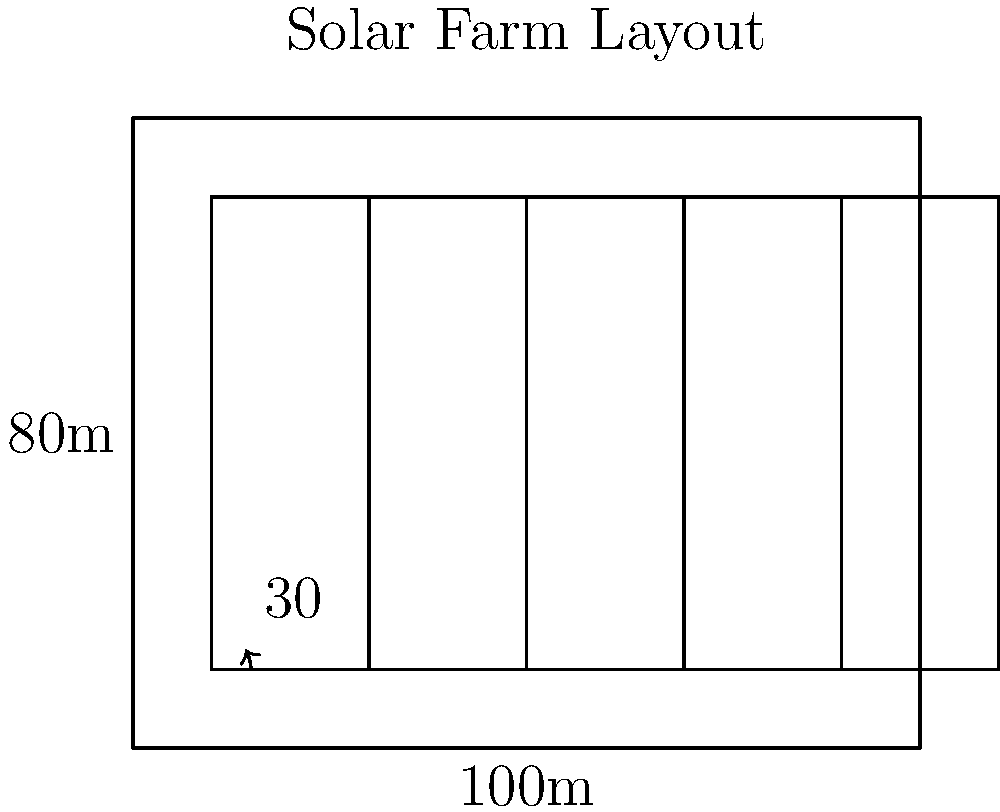A rectangular plot of land measuring 100m by 80m is available for a solar farm. Solar panels are to be arranged in rows, with each panel tilted at a 30° angle from the horizontal. To minimize shading, the distance between rows should be 2.5 times the vertical height of a tilted panel. If each panel is 20m wide and 60m long when laid flat, what is the maximum number of complete rows of panels that can be installed in this plot? To solve this problem, we need to follow these steps:

1) First, calculate the vertical height of a tilted panel:
   $h = 60m \cdot \sin(30°) = 60m \cdot 0.5 = 30m$

2) Calculate the required distance between rows:
   $d = 2.5 \cdot h = 2.5 \cdot 30m = 75m$

3) The total space needed for one row (including the gap):
   $\text{Total space} = 75m + 60m \cdot \cos(30°) = 75m + 60m \cdot 0.866 = 127m$

4) The available space is 80m (the width of the plot). To find the number of rows, divide the available space by the total space needed per row:
   $\text{Number of rows} = 80m \div 127m \approx 0.63$

5) Since we can only have complete rows, we round down to 0.

Therefore, it's not possible to install even one complete row of panels with the given constraints and land dimensions.
Answer: 0 rows 